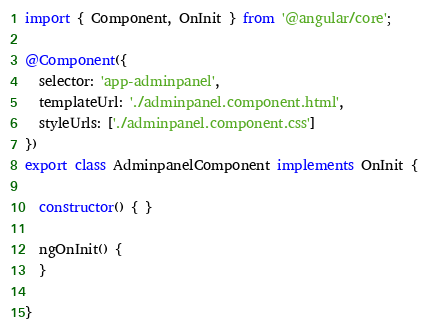<code> <loc_0><loc_0><loc_500><loc_500><_TypeScript_>import { Component, OnInit } from '@angular/core';

@Component({
  selector: 'app-adminpanel',
  templateUrl: './adminpanel.component.html',
  styleUrls: ['./adminpanel.component.css']
})
export class AdminpanelComponent implements OnInit {

  constructor() { }

  ngOnInit() {
  }

}
</code> 